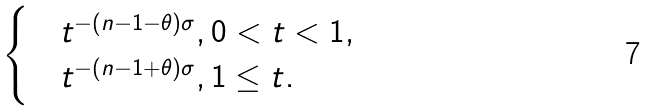Convert formula to latex. <formula><loc_0><loc_0><loc_500><loc_500>\begin{cases} & t ^ { - ( n - 1 - \theta ) \sigma } , 0 < t < 1 , \\ & t ^ { - ( n - 1 + \theta ) \sigma } , 1 \leq t . \end{cases}</formula> 